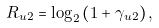<formula> <loc_0><loc_0><loc_500><loc_500>R _ { u 2 } = \log _ { 2 } \left ( 1 + \gamma _ { u 2 } \right ) ,</formula> 